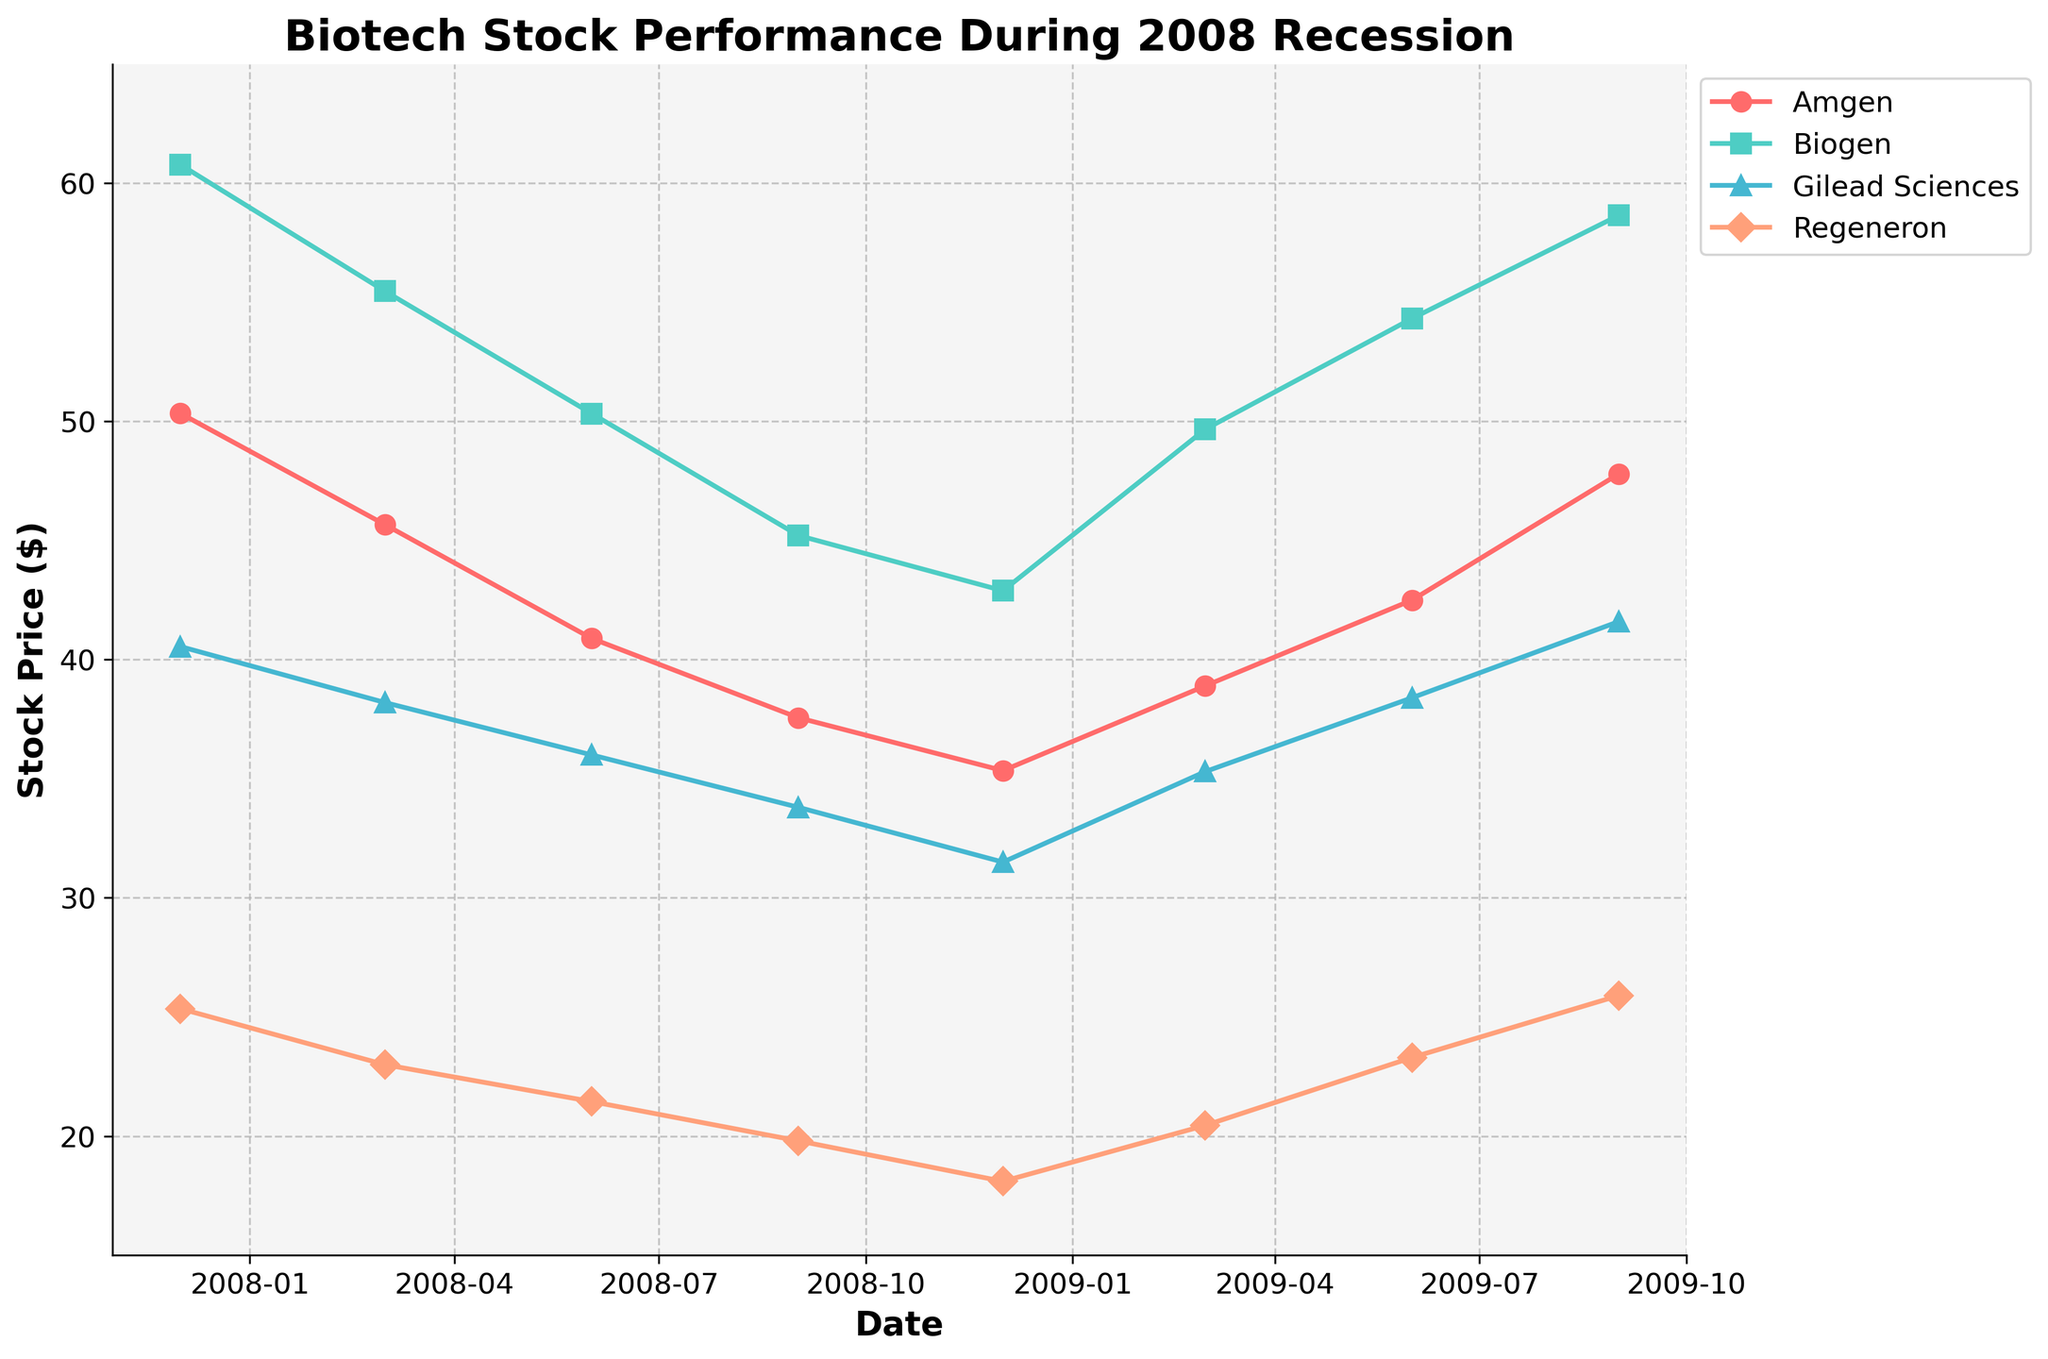What is the title of the plot? The title is usually located at the top of the plot. Here, it reads "Biotech Stock Performance During 2008 Recession".
Answer: Biotech Stock Performance During 2008 Recession Which company had the highest stock price in December 2008? By looking at the data points for December 2008 on the x-axis and locating the highest y-axis value among the companies, Biogen had the highest stock price at approximately $42.89.
Answer: Biogen How does the stock price of Gilead Sciences change from December 2007 to December 2008? Track the progress of Gilead Sciences on the plot from December 2007 to December 2008. The stock price fell from $40.55 to $31.50.
Answer: It decreased Which company's stock price recovered the most from its lowest point during the recession to September 2009? Identify the lowest point and the September 2009 value for each company. The differences are Amgen: $35.34 to $47.80 ($12.46), Biogen: $42.89 to $58.65 ($15.76), Gilead Sciences: $31.50 to $41.60 ($10.10), and Regeneron: $18.10 to $25.90 ($7.80). Biogen had the largest recovery.
Answer: Biogen What is the overall trend for Amgen's stock price during the plotted period? Observe the stock price movement from start to end. Amgen's price went down initially, then recovered towards the end.
Answer: Down, then up How many data points are plotted for each company? Count the number of points for each company based on the markers visible on the plot. There are 8 data points for each company.
Answer: 8 Which company had the lowest stock price in September 2009? Look for the data points on the plot by September 2009 and identify the lowest one, which is Regeneron at approximately $25.90.
Answer: Regeneron Did any company's stock price increase between March 2009 and June 2009? Check the slope of the lines between March 2009 and June 2009 for each company. All companies' stock prices increased during this period.
Answer: Yes Compare the stock prices of Biogen and Regeneron in June 2009. Which one was higher? Locate the June 2009 data points for both companies and compare the y-axis values. Biogen's stock price was higher at approximately $54.32 compared to Regeneron's $23.30.
Answer: Biogen Which company had a stock price above $50 before the recession started (December 2007)? Check the values at December 2007 for all companies. Both Amgen and Biogen had stock prices above $50, but Biogen was higher at approximately $60.78.
Answer: Biogen 